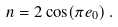Convert formula to latex. <formula><loc_0><loc_0><loc_500><loc_500>n = 2 \cos ( \pi e _ { 0 } ) \, .</formula> 